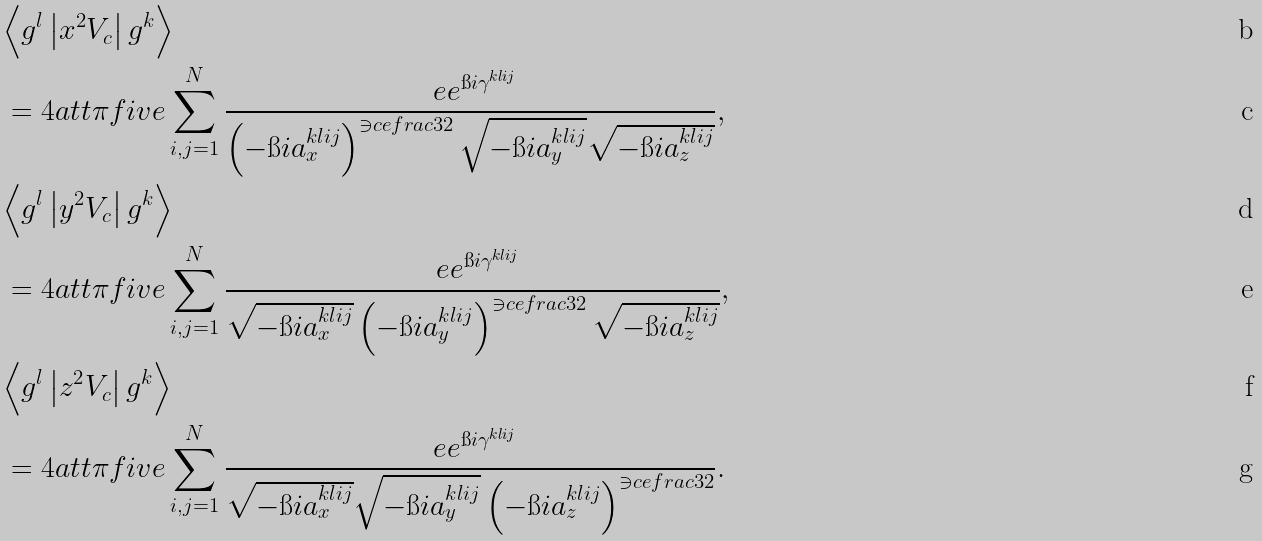<formula> <loc_0><loc_0><loc_500><loc_500>& \Big < g ^ { l } \left | x ^ { 2 } V _ { c } \right | g ^ { k } \Big > \\ & = 4 a t t \pi f i v e \sum _ { i , j = 1 } ^ { N } \frac { \ e e ^ { \i i { \gamma ^ { k l i j } } } } { \left ( - \i i a ^ { k l i j } _ { x } \right ) ^ { \ni c e f r a c { 3 } { 2 } } \sqrt { - \i i a ^ { k l i j } _ { y } } \sqrt { - \i i a ^ { k l i j } _ { z } } } , \\ & \Big < g ^ { l } \left | y ^ { 2 } V _ { c } \right | g ^ { k } \Big > \\ & = 4 a t t \pi f i v e \sum _ { i , j = 1 } ^ { N } \frac { \ e e ^ { \i i { \gamma ^ { k l i j } } } } { \sqrt { - \i i a ^ { k l i j } _ { x } } \left ( - \i i a ^ { k l i j } _ { y } \right ) ^ { \ni c e f r a c { 3 } { 2 } } \sqrt { - \i i a ^ { k l i j } _ { z } } } , \\ & \Big < g ^ { l } \left | z ^ { 2 } V _ { c } \right | g ^ { k } \Big > \\ & = 4 a t t \pi f i v e \sum _ { i , j = 1 } ^ { N } \frac { \ e e ^ { \i i { \gamma ^ { k l i j } } } } { \sqrt { - \i i a ^ { k l i j } _ { x } } \sqrt { - \i i a ^ { k l i j } _ { y } } \left ( - \i i a ^ { k l i j } _ { z } \right ) ^ { \ni c e f r a c { 3 } { 2 } } } .</formula> 